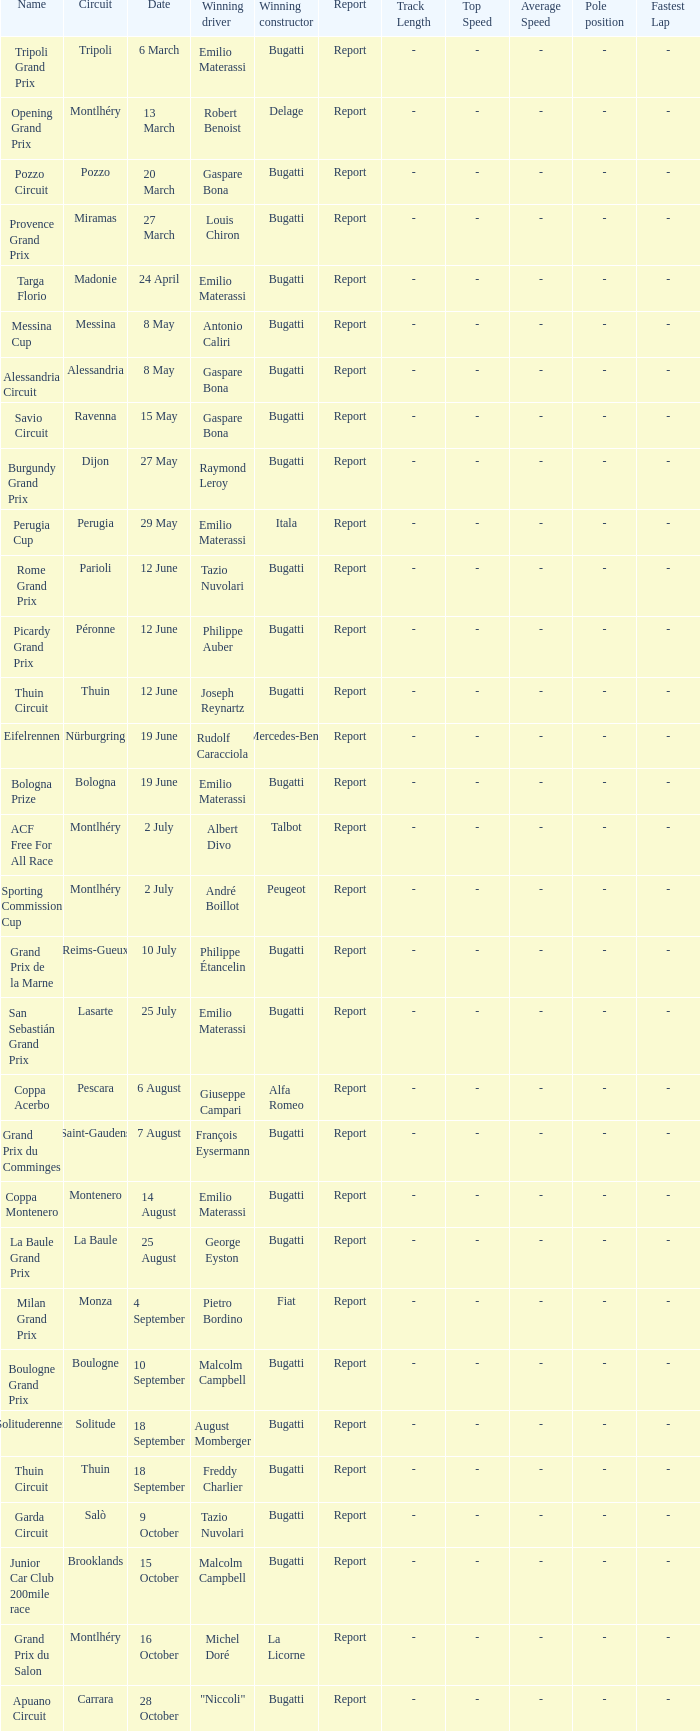Who was the winning constructor of the Grand Prix Du Salon ? La Licorne. 